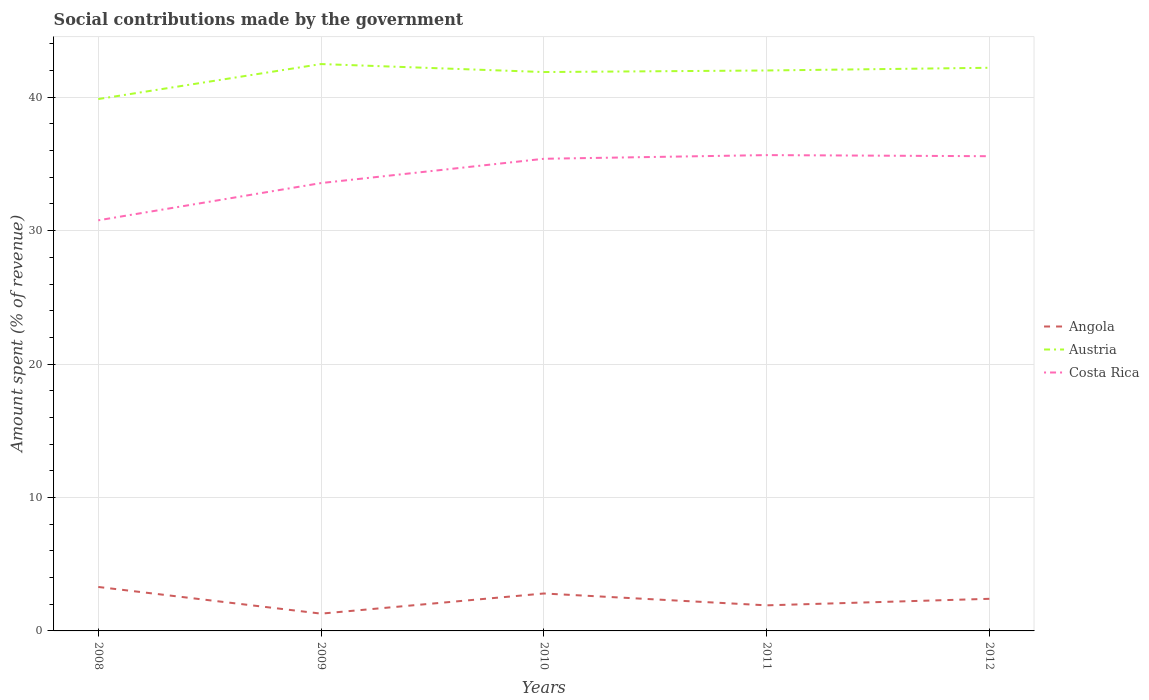How many different coloured lines are there?
Your answer should be very brief. 3. Does the line corresponding to Angola intersect with the line corresponding to Austria?
Keep it short and to the point. No. Is the number of lines equal to the number of legend labels?
Offer a very short reply. Yes. Across all years, what is the maximum amount spent (in %) on social contributions in Angola?
Provide a short and direct response. 1.3. In which year was the amount spent (in %) on social contributions in Angola maximum?
Provide a short and direct response. 2009. What is the total amount spent (in %) on social contributions in Austria in the graph?
Make the answer very short. -2.34. What is the difference between the highest and the second highest amount spent (in %) on social contributions in Costa Rica?
Ensure brevity in your answer.  4.89. What is the difference between the highest and the lowest amount spent (in %) on social contributions in Austria?
Give a very brief answer. 4. Is the amount spent (in %) on social contributions in Angola strictly greater than the amount spent (in %) on social contributions in Austria over the years?
Provide a short and direct response. Yes. How many lines are there?
Give a very brief answer. 3. How many years are there in the graph?
Make the answer very short. 5. Are the values on the major ticks of Y-axis written in scientific E-notation?
Your answer should be very brief. No. Does the graph contain any zero values?
Make the answer very short. No. Where does the legend appear in the graph?
Provide a succinct answer. Center right. How many legend labels are there?
Make the answer very short. 3. How are the legend labels stacked?
Ensure brevity in your answer.  Vertical. What is the title of the graph?
Provide a short and direct response. Social contributions made by the government. Does "Algeria" appear as one of the legend labels in the graph?
Ensure brevity in your answer.  No. What is the label or title of the X-axis?
Provide a short and direct response. Years. What is the label or title of the Y-axis?
Your answer should be very brief. Amount spent (% of revenue). What is the Amount spent (% of revenue) in Angola in 2008?
Your answer should be compact. 3.29. What is the Amount spent (% of revenue) of Austria in 2008?
Ensure brevity in your answer.  39.86. What is the Amount spent (% of revenue) of Costa Rica in 2008?
Your answer should be compact. 30.77. What is the Amount spent (% of revenue) of Angola in 2009?
Your answer should be compact. 1.3. What is the Amount spent (% of revenue) in Austria in 2009?
Your answer should be very brief. 42.48. What is the Amount spent (% of revenue) in Costa Rica in 2009?
Provide a short and direct response. 33.57. What is the Amount spent (% of revenue) in Angola in 2010?
Make the answer very short. 2.81. What is the Amount spent (% of revenue) in Austria in 2010?
Your answer should be compact. 41.89. What is the Amount spent (% of revenue) in Costa Rica in 2010?
Your response must be concise. 35.39. What is the Amount spent (% of revenue) of Angola in 2011?
Provide a succinct answer. 1.92. What is the Amount spent (% of revenue) of Austria in 2011?
Your response must be concise. 42. What is the Amount spent (% of revenue) of Costa Rica in 2011?
Offer a terse response. 35.66. What is the Amount spent (% of revenue) of Angola in 2012?
Ensure brevity in your answer.  2.41. What is the Amount spent (% of revenue) in Austria in 2012?
Keep it short and to the point. 42.21. What is the Amount spent (% of revenue) of Costa Rica in 2012?
Give a very brief answer. 35.58. Across all years, what is the maximum Amount spent (% of revenue) in Angola?
Your response must be concise. 3.29. Across all years, what is the maximum Amount spent (% of revenue) of Austria?
Your answer should be compact. 42.48. Across all years, what is the maximum Amount spent (% of revenue) of Costa Rica?
Provide a succinct answer. 35.66. Across all years, what is the minimum Amount spent (% of revenue) of Angola?
Your answer should be compact. 1.3. Across all years, what is the minimum Amount spent (% of revenue) of Austria?
Offer a terse response. 39.86. Across all years, what is the minimum Amount spent (% of revenue) of Costa Rica?
Keep it short and to the point. 30.77. What is the total Amount spent (% of revenue) in Angola in the graph?
Ensure brevity in your answer.  11.72. What is the total Amount spent (% of revenue) in Austria in the graph?
Offer a terse response. 208.44. What is the total Amount spent (% of revenue) of Costa Rica in the graph?
Keep it short and to the point. 170.96. What is the difference between the Amount spent (% of revenue) of Angola in 2008 and that in 2009?
Keep it short and to the point. 2. What is the difference between the Amount spent (% of revenue) of Austria in 2008 and that in 2009?
Provide a succinct answer. -2.62. What is the difference between the Amount spent (% of revenue) of Costa Rica in 2008 and that in 2009?
Your response must be concise. -2.79. What is the difference between the Amount spent (% of revenue) of Angola in 2008 and that in 2010?
Your answer should be very brief. 0.49. What is the difference between the Amount spent (% of revenue) of Austria in 2008 and that in 2010?
Make the answer very short. -2.02. What is the difference between the Amount spent (% of revenue) of Costa Rica in 2008 and that in 2010?
Provide a short and direct response. -4.61. What is the difference between the Amount spent (% of revenue) in Angola in 2008 and that in 2011?
Your answer should be very brief. 1.38. What is the difference between the Amount spent (% of revenue) in Austria in 2008 and that in 2011?
Your response must be concise. -2.14. What is the difference between the Amount spent (% of revenue) in Costa Rica in 2008 and that in 2011?
Offer a terse response. -4.89. What is the difference between the Amount spent (% of revenue) in Angola in 2008 and that in 2012?
Your answer should be compact. 0.89. What is the difference between the Amount spent (% of revenue) of Austria in 2008 and that in 2012?
Provide a short and direct response. -2.34. What is the difference between the Amount spent (% of revenue) in Costa Rica in 2008 and that in 2012?
Offer a very short reply. -4.8. What is the difference between the Amount spent (% of revenue) in Angola in 2009 and that in 2010?
Ensure brevity in your answer.  -1.51. What is the difference between the Amount spent (% of revenue) of Austria in 2009 and that in 2010?
Give a very brief answer. 0.6. What is the difference between the Amount spent (% of revenue) in Costa Rica in 2009 and that in 2010?
Ensure brevity in your answer.  -1.82. What is the difference between the Amount spent (% of revenue) in Angola in 2009 and that in 2011?
Your answer should be compact. -0.62. What is the difference between the Amount spent (% of revenue) of Austria in 2009 and that in 2011?
Provide a succinct answer. 0.48. What is the difference between the Amount spent (% of revenue) of Costa Rica in 2009 and that in 2011?
Keep it short and to the point. -2.1. What is the difference between the Amount spent (% of revenue) of Angola in 2009 and that in 2012?
Provide a succinct answer. -1.11. What is the difference between the Amount spent (% of revenue) in Austria in 2009 and that in 2012?
Your response must be concise. 0.28. What is the difference between the Amount spent (% of revenue) of Costa Rica in 2009 and that in 2012?
Keep it short and to the point. -2.01. What is the difference between the Amount spent (% of revenue) in Angola in 2010 and that in 2011?
Provide a short and direct response. 0.89. What is the difference between the Amount spent (% of revenue) of Austria in 2010 and that in 2011?
Your answer should be very brief. -0.12. What is the difference between the Amount spent (% of revenue) in Costa Rica in 2010 and that in 2011?
Give a very brief answer. -0.28. What is the difference between the Amount spent (% of revenue) of Angola in 2010 and that in 2012?
Your answer should be very brief. 0.4. What is the difference between the Amount spent (% of revenue) in Austria in 2010 and that in 2012?
Your response must be concise. -0.32. What is the difference between the Amount spent (% of revenue) in Costa Rica in 2010 and that in 2012?
Keep it short and to the point. -0.19. What is the difference between the Amount spent (% of revenue) in Angola in 2011 and that in 2012?
Provide a succinct answer. -0.49. What is the difference between the Amount spent (% of revenue) of Austria in 2011 and that in 2012?
Offer a very short reply. -0.2. What is the difference between the Amount spent (% of revenue) in Costa Rica in 2011 and that in 2012?
Give a very brief answer. 0.08. What is the difference between the Amount spent (% of revenue) in Angola in 2008 and the Amount spent (% of revenue) in Austria in 2009?
Provide a short and direct response. -39.19. What is the difference between the Amount spent (% of revenue) in Angola in 2008 and the Amount spent (% of revenue) in Costa Rica in 2009?
Provide a short and direct response. -30.27. What is the difference between the Amount spent (% of revenue) of Austria in 2008 and the Amount spent (% of revenue) of Costa Rica in 2009?
Make the answer very short. 6.3. What is the difference between the Amount spent (% of revenue) of Angola in 2008 and the Amount spent (% of revenue) of Austria in 2010?
Provide a succinct answer. -38.59. What is the difference between the Amount spent (% of revenue) in Angola in 2008 and the Amount spent (% of revenue) in Costa Rica in 2010?
Provide a succinct answer. -32.09. What is the difference between the Amount spent (% of revenue) of Austria in 2008 and the Amount spent (% of revenue) of Costa Rica in 2010?
Your response must be concise. 4.48. What is the difference between the Amount spent (% of revenue) in Angola in 2008 and the Amount spent (% of revenue) in Austria in 2011?
Provide a short and direct response. -38.71. What is the difference between the Amount spent (% of revenue) of Angola in 2008 and the Amount spent (% of revenue) of Costa Rica in 2011?
Provide a short and direct response. -32.37. What is the difference between the Amount spent (% of revenue) in Austria in 2008 and the Amount spent (% of revenue) in Costa Rica in 2011?
Your answer should be compact. 4.2. What is the difference between the Amount spent (% of revenue) in Angola in 2008 and the Amount spent (% of revenue) in Austria in 2012?
Offer a very short reply. -38.91. What is the difference between the Amount spent (% of revenue) of Angola in 2008 and the Amount spent (% of revenue) of Costa Rica in 2012?
Your answer should be very brief. -32.28. What is the difference between the Amount spent (% of revenue) of Austria in 2008 and the Amount spent (% of revenue) of Costa Rica in 2012?
Provide a short and direct response. 4.28. What is the difference between the Amount spent (% of revenue) of Angola in 2009 and the Amount spent (% of revenue) of Austria in 2010?
Provide a succinct answer. -40.59. What is the difference between the Amount spent (% of revenue) of Angola in 2009 and the Amount spent (% of revenue) of Costa Rica in 2010?
Offer a very short reply. -34.09. What is the difference between the Amount spent (% of revenue) of Austria in 2009 and the Amount spent (% of revenue) of Costa Rica in 2010?
Your answer should be compact. 7.1. What is the difference between the Amount spent (% of revenue) in Angola in 2009 and the Amount spent (% of revenue) in Austria in 2011?
Your answer should be very brief. -40.71. What is the difference between the Amount spent (% of revenue) of Angola in 2009 and the Amount spent (% of revenue) of Costa Rica in 2011?
Your answer should be very brief. -34.37. What is the difference between the Amount spent (% of revenue) of Austria in 2009 and the Amount spent (% of revenue) of Costa Rica in 2011?
Ensure brevity in your answer.  6.82. What is the difference between the Amount spent (% of revenue) in Angola in 2009 and the Amount spent (% of revenue) in Austria in 2012?
Your answer should be very brief. -40.91. What is the difference between the Amount spent (% of revenue) in Angola in 2009 and the Amount spent (% of revenue) in Costa Rica in 2012?
Offer a very short reply. -34.28. What is the difference between the Amount spent (% of revenue) of Austria in 2009 and the Amount spent (% of revenue) of Costa Rica in 2012?
Ensure brevity in your answer.  6.91. What is the difference between the Amount spent (% of revenue) of Angola in 2010 and the Amount spent (% of revenue) of Austria in 2011?
Offer a terse response. -39.2. What is the difference between the Amount spent (% of revenue) in Angola in 2010 and the Amount spent (% of revenue) in Costa Rica in 2011?
Offer a terse response. -32.86. What is the difference between the Amount spent (% of revenue) in Austria in 2010 and the Amount spent (% of revenue) in Costa Rica in 2011?
Provide a succinct answer. 6.22. What is the difference between the Amount spent (% of revenue) of Angola in 2010 and the Amount spent (% of revenue) of Austria in 2012?
Keep it short and to the point. -39.4. What is the difference between the Amount spent (% of revenue) of Angola in 2010 and the Amount spent (% of revenue) of Costa Rica in 2012?
Provide a short and direct response. -32.77. What is the difference between the Amount spent (% of revenue) in Austria in 2010 and the Amount spent (% of revenue) in Costa Rica in 2012?
Offer a very short reply. 6.31. What is the difference between the Amount spent (% of revenue) of Angola in 2011 and the Amount spent (% of revenue) of Austria in 2012?
Give a very brief answer. -40.29. What is the difference between the Amount spent (% of revenue) of Angola in 2011 and the Amount spent (% of revenue) of Costa Rica in 2012?
Your answer should be compact. -33.66. What is the difference between the Amount spent (% of revenue) of Austria in 2011 and the Amount spent (% of revenue) of Costa Rica in 2012?
Your response must be concise. 6.43. What is the average Amount spent (% of revenue) of Angola per year?
Offer a very short reply. 2.34. What is the average Amount spent (% of revenue) of Austria per year?
Keep it short and to the point. 41.69. What is the average Amount spent (% of revenue) of Costa Rica per year?
Make the answer very short. 34.19. In the year 2008, what is the difference between the Amount spent (% of revenue) in Angola and Amount spent (% of revenue) in Austria?
Provide a short and direct response. -36.57. In the year 2008, what is the difference between the Amount spent (% of revenue) in Angola and Amount spent (% of revenue) in Costa Rica?
Provide a short and direct response. -27.48. In the year 2008, what is the difference between the Amount spent (% of revenue) of Austria and Amount spent (% of revenue) of Costa Rica?
Make the answer very short. 9.09. In the year 2009, what is the difference between the Amount spent (% of revenue) in Angola and Amount spent (% of revenue) in Austria?
Provide a succinct answer. -41.19. In the year 2009, what is the difference between the Amount spent (% of revenue) in Angola and Amount spent (% of revenue) in Costa Rica?
Offer a very short reply. -32.27. In the year 2009, what is the difference between the Amount spent (% of revenue) in Austria and Amount spent (% of revenue) in Costa Rica?
Offer a very short reply. 8.92. In the year 2010, what is the difference between the Amount spent (% of revenue) in Angola and Amount spent (% of revenue) in Austria?
Provide a short and direct response. -39.08. In the year 2010, what is the difference between the Amount spent (% of revenue) in Angola and Amount spent (% of revenue) in Costa Rica?
Offer a very short reply. -32.58. In the year 2010, what is the difference between the Amount spent (% of revenue) of Austria and Amount spent (% of revenue) of Costa Rica?
Provide a short and direct response. 6.5. In the year 2011, what is the difference between the Amount spent (% of revenue) in Angola and Amount spent (% of revenue) in Austria?
Provide a short and direct response. -40.09. In the year 2011, what is the difference between the Amount spent (% of revenue) of Angola and Amount spent (% of revenue) of Costa Rica?
Give a very brief answer. -33.74. In the year 2011, what is the difference between the Amount spent (% of revenue) of Austria and Amount spent (% of revenue) of Costa Rica?
Make the answer very short. 6.34. In the year 2012, what is the difference between the Amount spent (% of revenue) in Angola and Amount spent (% of revenue) in Austria?
Offer a very short reply. -39.8. In the year 2012, what is the difference between the Amount spent (% of revenue) of Angola and Amount spent (% of revenue) of Costa Rica?
Offer a very short reply. -33.17. In the year 2012, what is the difference between the Amount spent (% of revenue) of Austria and Amount spent (% of revenue) of Costa Rica?
Offer a terse response. 6.63. What is the ratio of the Amount spent (% of revenue) of Angola in 2008 to that in 2009?
Your answer should be very brief. 2.54. What is the ratio of the Amount spent (% of revenue) of Austria in 2008 to that in 2009?
Offer a terse response. 0.94. What is the ratio of the Amount spent (% of revenue) of Costa Rica in 2008 to that in 2009?
Offer a terse response. 0.92. What is the ratio of the Amount spent (% of revenue) of Angola in 2008 to that in 2010?
Offer a very short reply. 1.17. What is the ratio of the Amount spent (% of revenue) of Austria in 2008 to that in 2010?
Provide a short and direct response. 0.95. What is the ratio of the Amount spent (% of revenue) of Costa Rica in 2008 to that in 2010?
Keep it short and to the point. 0.87. What is the ratio of the Amount spent (% of revenue) of Angola in 2008 to that in 2011?
Your response must be concise. 1.72. What is the ratio of the Amount spent (% of revenue) of Austria in 2008 to that in 2011?
Your response must be concise. 0.95. What is the ratio of the Amount spent (% of revenue) of Costa Rica in 2008 to that in 2011?
Provide a short and direct response. 0.86. What is the ratio of the Amount spent (% of revenue) in Angola in 2008 to that in 2012?
Your response must be concise. 1.37. What is the ratio of the Amount spent (% of revenue) in Austria in 2008 to that in 2012?
Ensure brevity in your answer.  0.94. What is the ratio of the Amount spent (% of revenue) in Costa Rica in 2008 to that in 2012?
Offer a very short reply. 0.86. What is the ratio of the Amount spent (% of revenue) in Angola in 2009 to that in 2010?
Keep it short and to the point. 0.46. What is the ratio of the Amount spent (% of revenue) in Austria in 2009 to that in 2010?
Keep it short and to the point. 1.01. What is the ratio of the Amount spent (% of revenue) of Costa Rica in 2009 to that in 2010?
Your answer should be very brief. 0.95. What is the ratio of the Amount spent (% of revenue) in Angola in 2009 to that in 2011?
Offer a terse response. 0.68. What is the ratio of the Amount spent (% of revenue) in Austria in 2009 to that in 2011?
Keep it short and to the point. 1.01. What is the ratio of the Amount spent (% of revenue) in Angola in 2009 to that in 2012?
Offer a very short reply. 0.54. What is the ratio of the Amount spent (% of revenue) in Austria in 2009 to that in 2012?
Your response must be concise. 1.01. What is the ratio of the Amount spent (% of revenue) in Costa Rica in 2009 to that in 2012?
Give a very brief answer. 0.94. What is the ratio of the Amount spent (% of revenue) of Angola in 2010 to that in 2011?
Ensure brevity in your answer.  1.46. What is the ratio of the Amount spent (% of revenue) of Austria in 2010 to that in 2011?
Offer a terse response. 1. What is the ratio of the Amount spent (% of revenue) of Angola in 2010 to that in 2012?
Give a very brief answer. 1.17. What is the ratio of the Amount spent (% of revenue) of Austria in 2010 to that in 2012?
Your answer should be compact. 0.99. What is the ratio of the Amount spent (% of revenue) of Costa Rica in 2010 to that in 2012?
Ensure brevity in your answer.  0.99. What is the ratio of the Amount spent (% of revenue) of Angola in 2011 to that in 2012?
Offer a very short reply. 0.8. What is the ratio of the Amount spent (% of revenue) of Costa Rica in 2011 to that in 2012?
Your answer should be compact. 1. What is the difference between the highest and the second highest Amount spent (% of revenue) of Angola?
Provide a succinct answer. 0.49. What is the difference between the highest and the second highest Amount spent (% of revenue) of Austria?
Your answer should be very brief. 0.28. What is the difference between the highest and the second highest Amount spent (% of revenue) in Costa Rica?
Offer a terse response. 0.08. What is the difference between the highest and the lowest Amount spent (% of revenue) of Angola?
Give a very brief answer. 2. What is the difference between the highest and the lowest Amount spent (% of revenue) in Austria?
Make the answer very short. 2.62. What is the difference between the highest and the lowest Amount spent (% of revenue) of Costa Rica?
Offer a terse response. 4.89. 